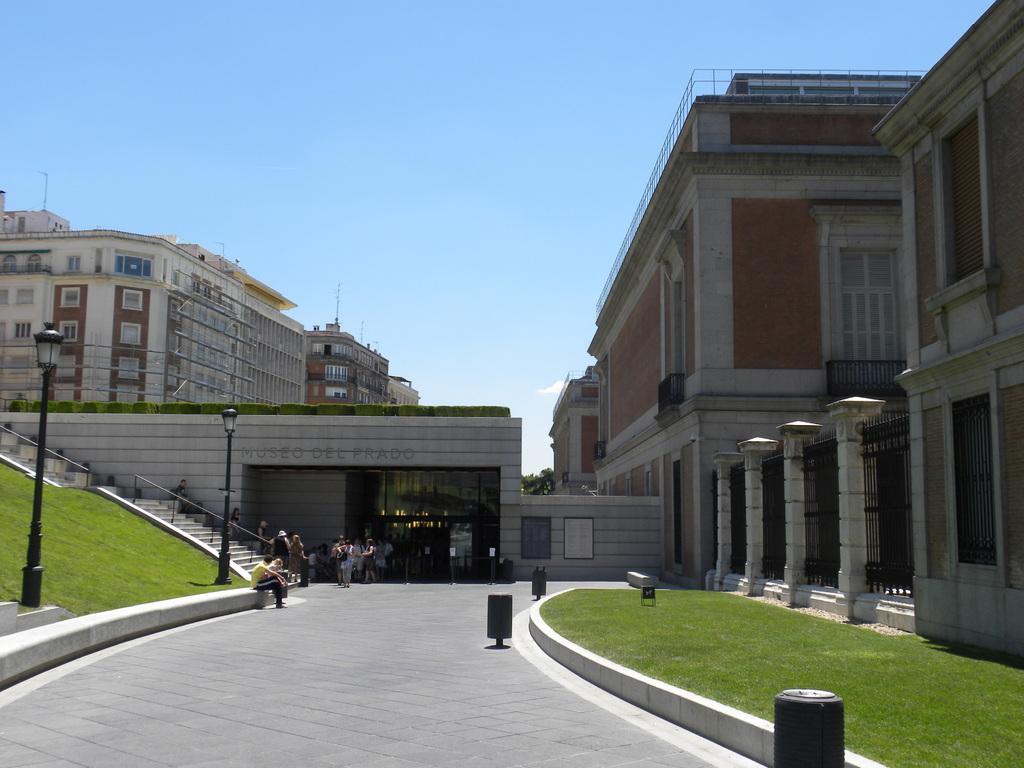How would you summarize this image in a sentence or two? This image is taken outdoors. At the bottom of the image there is a floor and a ground with grass on it. At the top of the image there is a sky with clouds. On the left side of the image there are two street lights and a staircase without railing. In the background there are a few buildings with walls, windows, doors, pillars, railings, balconies and roofs. In the middle of the image a few people are standing on the floor and a few are sitting. 